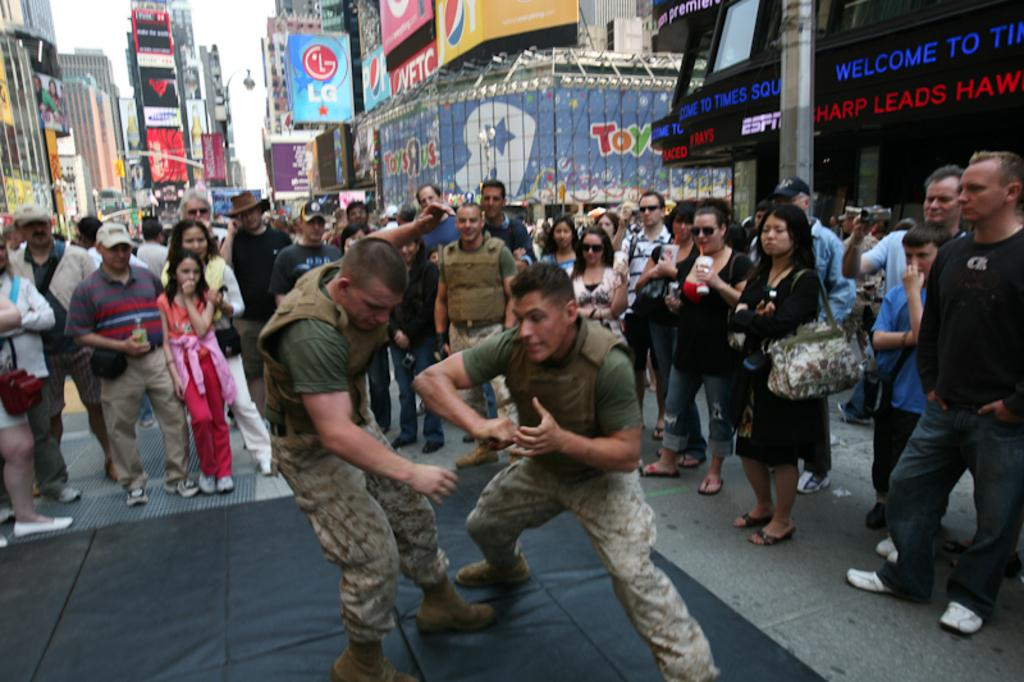How many people are in the image? There is a group of people in the image. Where are the people located in the image? The people are standing on the road. What can be seen in the background of the image? There are buildings and banners in the background of the image. What is visible in the sky in the image? The sky is visible in the background of the image. How many babies are crawling on the sand in the image? There are no babies or sand present in the image. 